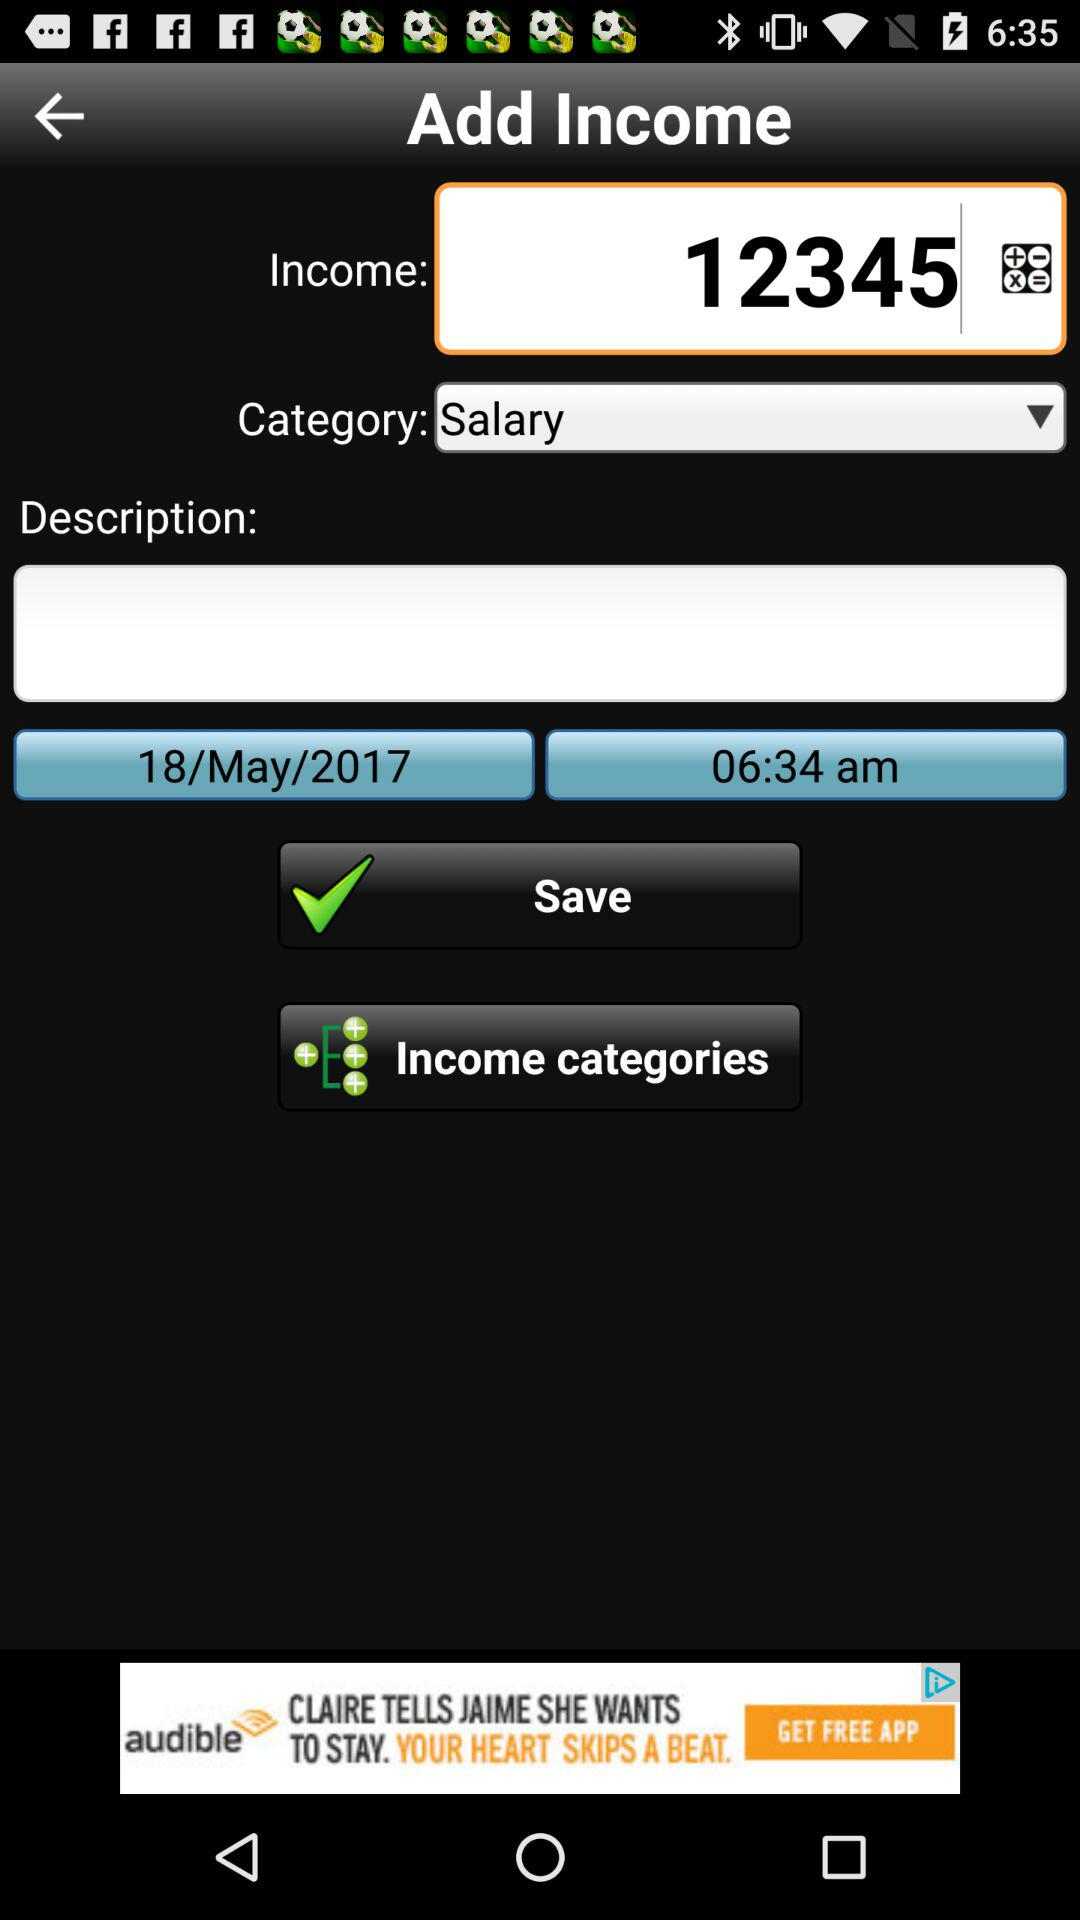What is the total amount of income and salary?
Answer the question using a single word or phrase. 12345 